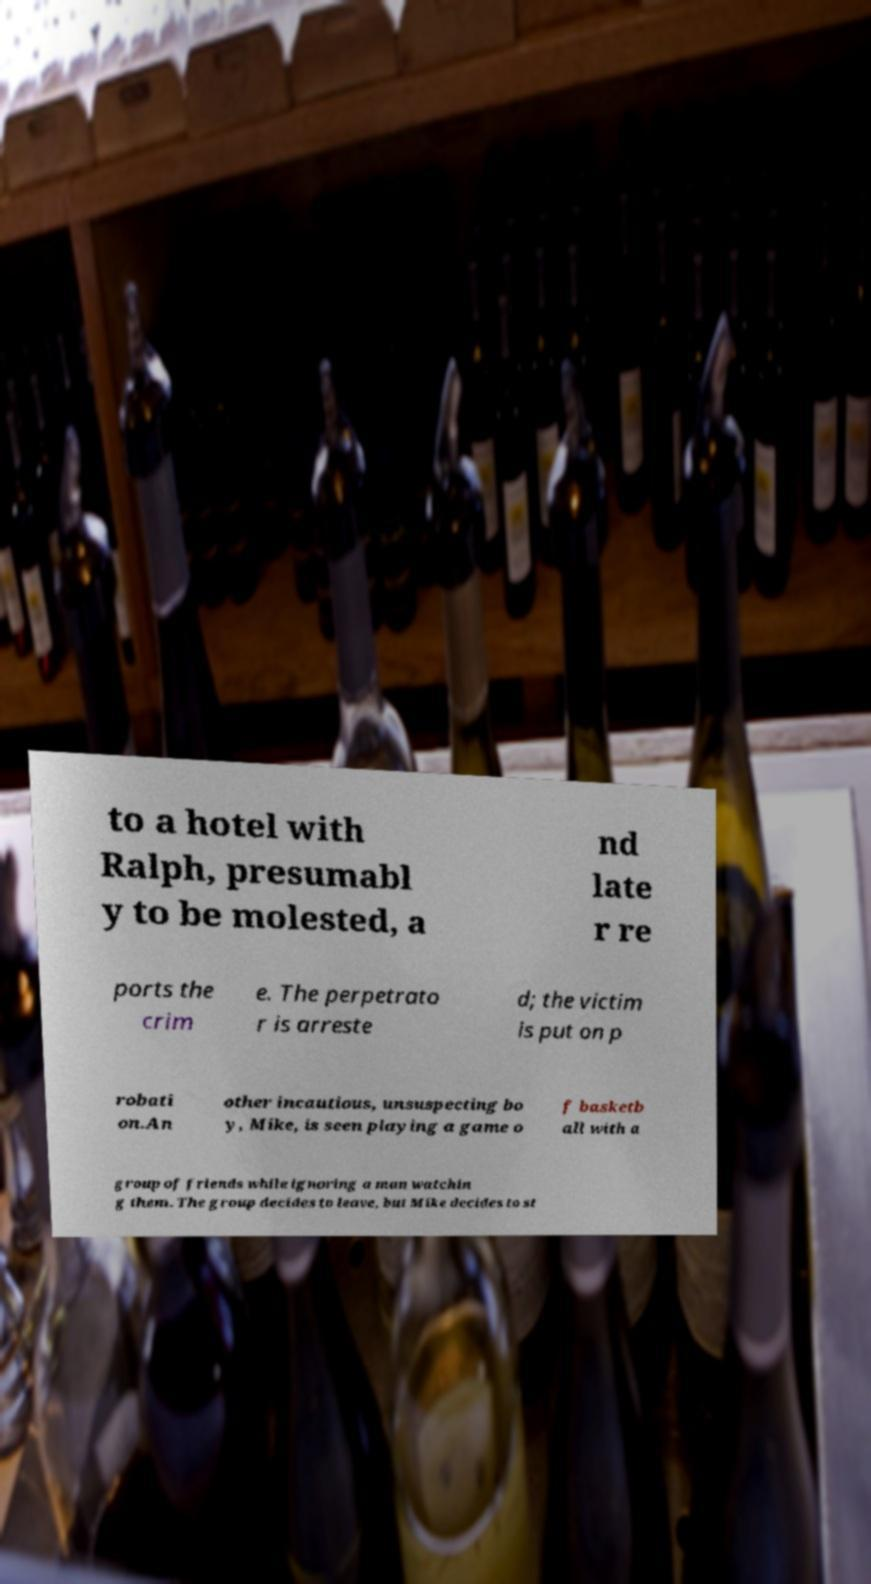Could you extract and type out the text from this image? to a hotel with Ralph, presumabl y to be molested, a nd late r re ports the crim e. The perpetrato r is arreste d; the victim is put on p robati on.An other incautious, unsuspecting bo y, Mike, is seen playing a game o f basketb all with a group of friends while ignoring a man watchin g them. The group decides to leave, but Mike decides to st 